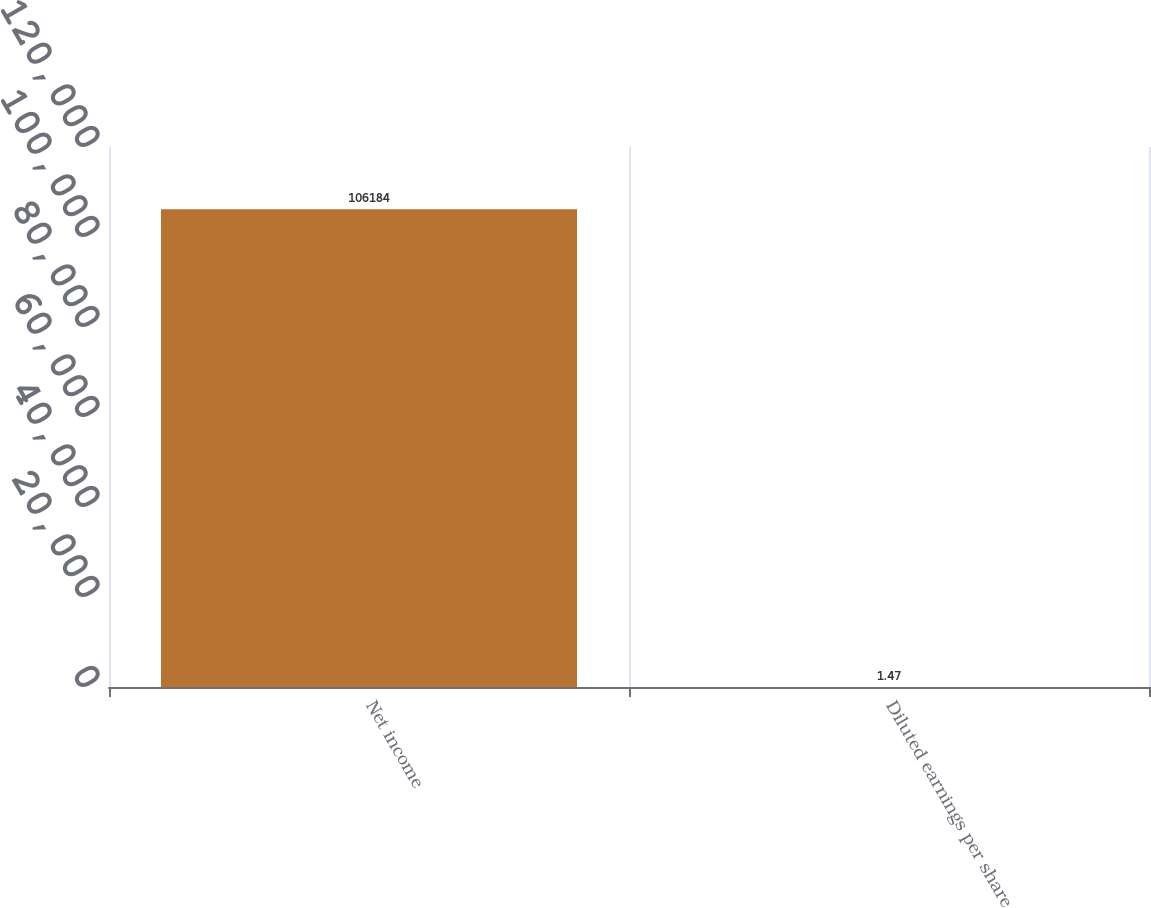Convert chart. <chart><loc_0><loc_0><loc_500><loc_500><bar_chart><fcel>Net income<fcel>Diluted earnings per share<nl><fcel>106184<fcel>1.47<nl></chart> 